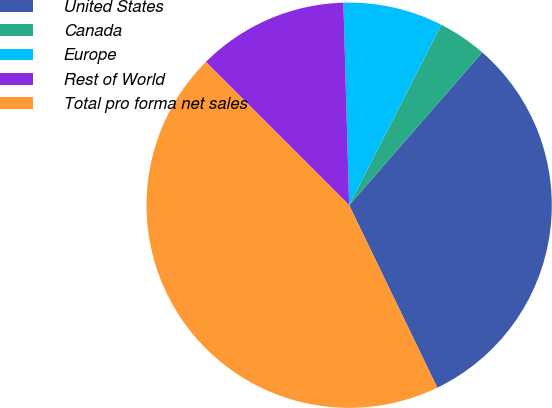<chart> <loc_0><loc_0><loc_500><loc_500><pie_chart><fcel>United States<fcel>Canada<fcel>Europe<fcel>Rest of World<fcel>Total pro forma net sales<nl><fcel>31.43%<fcel>3.89%<fcel>7.97%<fcel>12.05%<fcel>44.66%<nl></chart> 